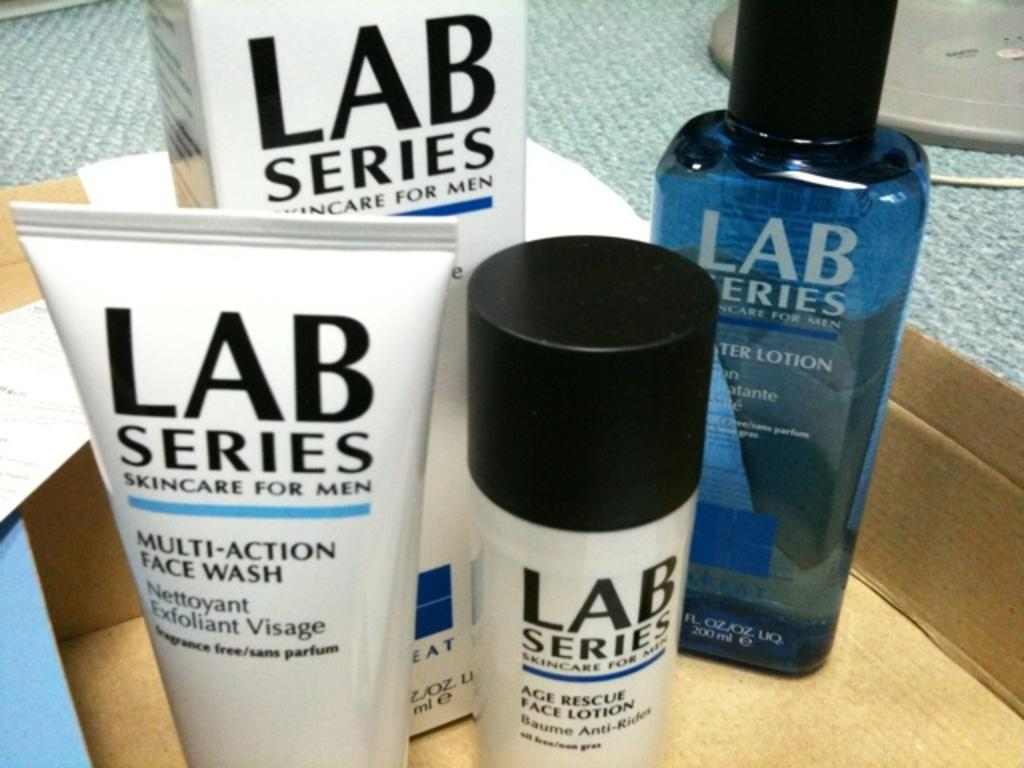<image>
Relay a brief, clear account of the picture shown. Men's skin care products are inside of a box. 